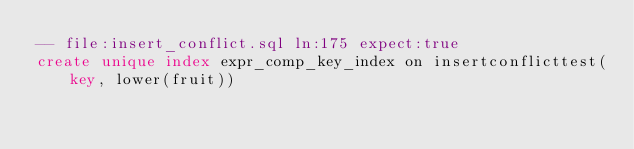Convert code to text. <code><loc_0><loc_0><loc_500><loc_500><_SQL_>-- file:insert_conflict.sql ln:175 expect:true
create unique index expr_comp_key_index on insertconflicttest(key, lower(fruit))
</code> 